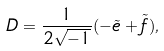Convert formula to latex. <formula><loc_0><loc_0><loc_500><loc_500>D = \frac { 1 } { 2 \sqrt { - 1 } } ( - \tilde { e } + \tilde { f } ) ,</formula> 